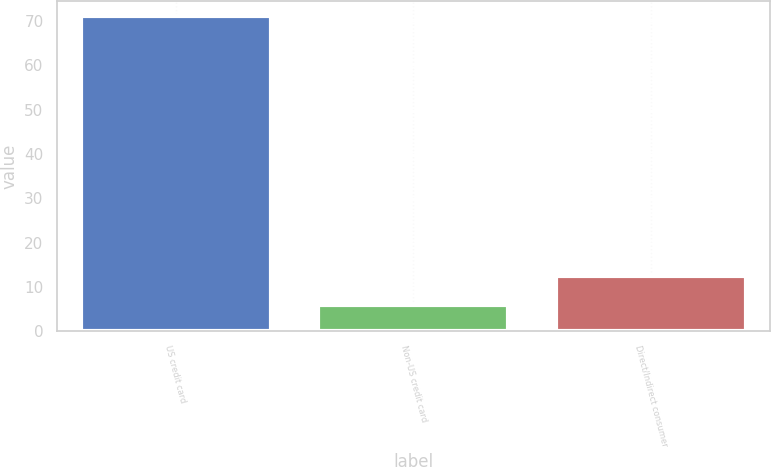Convert chart. <chart><loc_0><loc_0><loc_500><loc_500><bar_chart><fcel>US credit card<fcel>Non-US credit card<fcel>Direct/Indirect consumer<nl><fcel>71<fcel>6<fcel>12.5<nl></chart> 